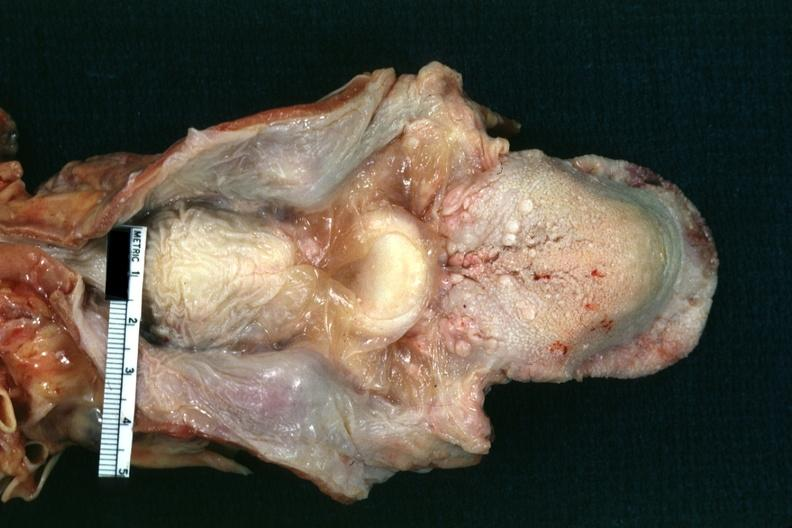does this image show edema well shown?
Answer the question using a single word or phrase. Yes 